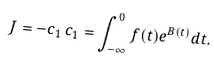Convert formula to latex. <formula><loc_0><loc_0><loc_500><loc_500>J = - c _ { 1 } \, c _ { 1 } = \int _ { - \infty } ^ { 0 } f ( t ) e ^ { B ( t ) } d t .</formula> 